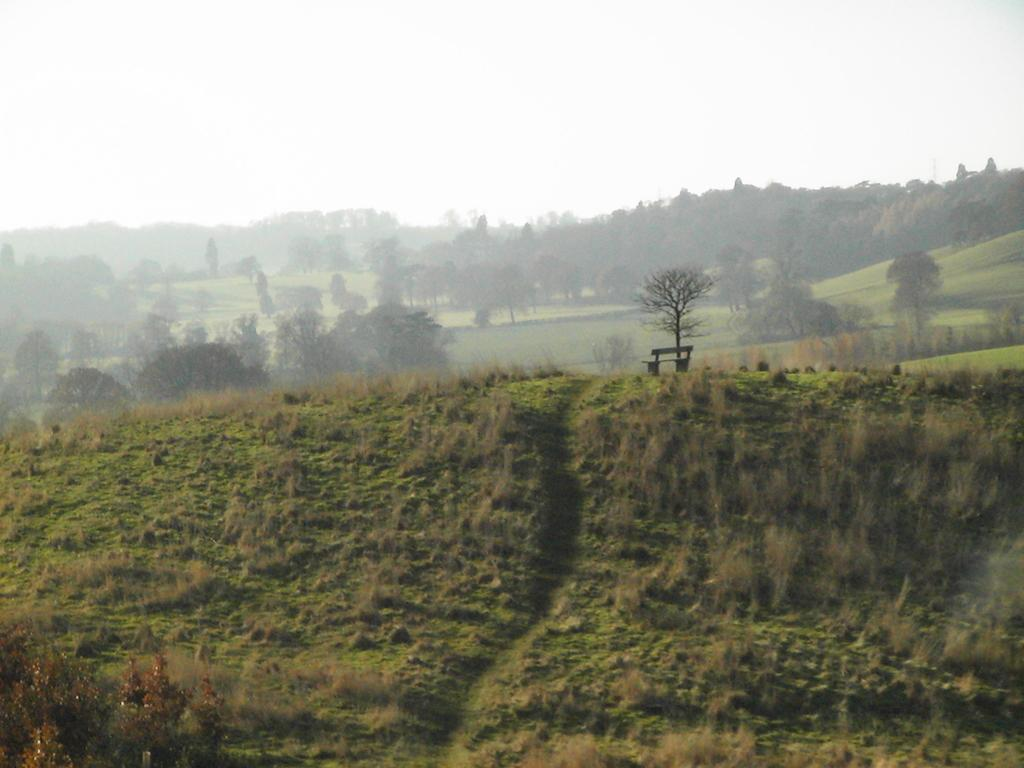What type of seating is present in the image? There is a bench in the image. What type of ground surface is visible in the image? There is grass in the image. What type of vegetation can be seen in the image? There are plants and trees in the image. What is visible in the background of the image? The sky is visible in the background of the image. How many beds are visible in the image? There are no beds present in the image. What type of educational institution can be seen in the image? There is no school present in the image. 